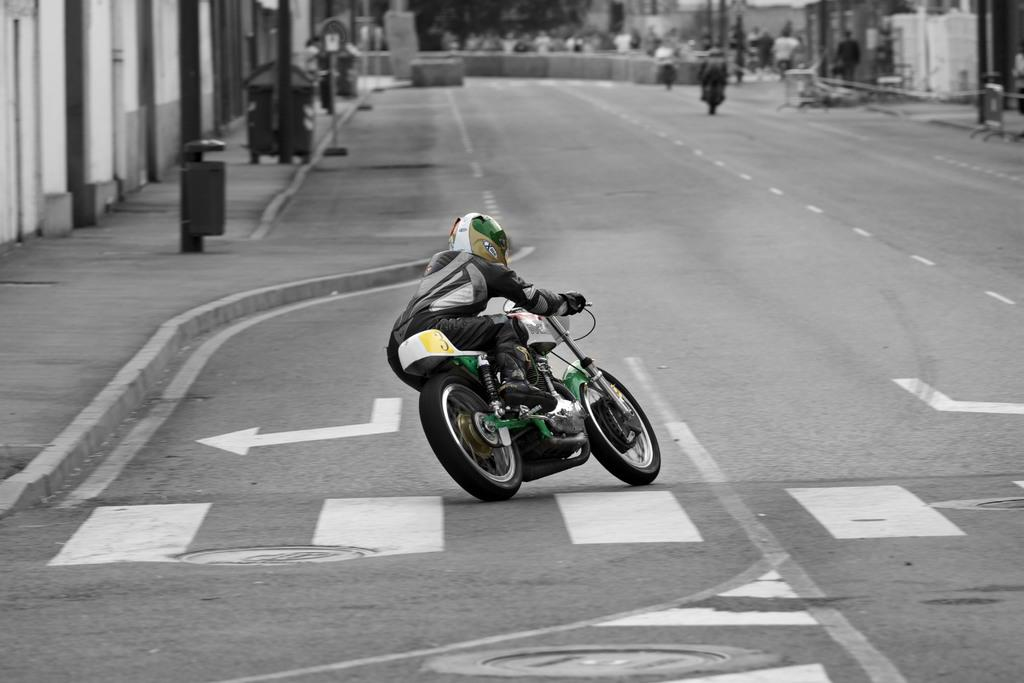What is the main subject of the image? There is a person riding a bike in the image. Where is the person riding the bike? The person is on the road. What can be seen in the background of the image? There is a pole and a building in the background of the image. Are there any other people in the image? Yes, there are other persons riding bikes in the background of the image. What type of oatmeal is the person eating while riding the bike in the image? There is no oatmeal present in the image, and the person is not eating anything while riding the bike. How many lizards can be seen on the person's bike in the image? There are no lizards present in the image, and therefore none can be seen on the person's bike. 